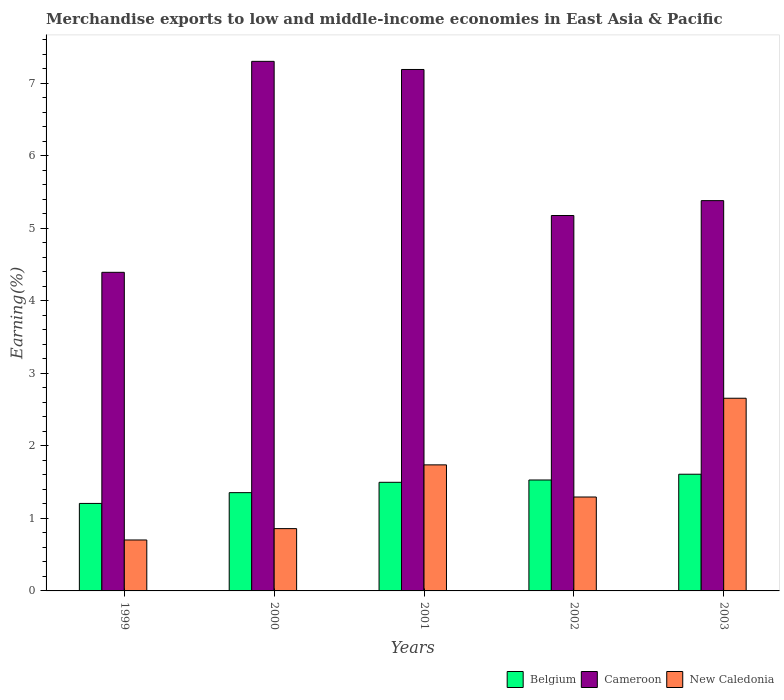How many different coloured bars are there?
Provide a short and direct response. 3. How many groups of bars are there?
Keep it short and to the point. 5. How many bars are there on the 3rd tick from the right?
Provide a succinct answer. 3. What is the percentage of amount earned from merchandise exports in Cameroon in 2002?
Keep it short and to the point. 5.18. Across all years, what is the maximum percentage of amount earned from merchandise exports in Cameroon?
Give a very brief answer. 7.31. Across all years, what is the minimum percentage of amount earned from merchandise exports in Cameroon?
Offer a very short reply. 4.39. In which year was the percentage of amount earned from merchandise exports in Belgium minimum?
Offer a terse response. 1999. What is the total percentage of amount earned from merchandise exports in New Caledonia in the graph?
Your answer should be very brief. 7.25. What is the difference between the percentage of amount earned from merchandise exports in New Caledonia in 2002 and that in 2003?
Provide a succinct answer. -1.36. What is the difference between the percentage of amount earned from merchandise exports in New Caledonia in 2000 and the percentage of amount earned from merchandise exports in Belgium in 2002?
Make the answer very short. -0.67. What is the average percentage of amount earned from merchandise exports in New Caledonia per year?
Offer a very short reply. 1.45. In the year 1999, what is the difference between the percentage of amount earned from merchandise exports in Belgium and percentage of amount earned from merchandise exports in New Caledonia?
Give a very brief answer. 0.5. In how many years, is the percentage of amount earned from merchandise exports in Cameroon greater than 4.6 %?
Offer a terse response. 4. What is the ratio of the percentage of amount earned from merchandise exports in New Caledonia in 2001 to that in 2003?
Offer a very short reply. 0.65. Is the percentage of amount earned from merchandise exports in Belgium in 1999 less than that in 2002?
Your answer should be compact. Yes. What is the difference between the highest and the second highest percentage of amount earned from merchandise exports in Cameroon?
Your response must be concise. 0.11. What is the difference between the highest and the lowest percentage of amount earned from merchandise exports in New Caledonia?
Offer a very short reply. 1.96. What does the 3rd bar from the left in 2003 represents?
Ensure brevity in your answer.  New Caledonia. What does the 3rd bar from the right in 1999 represents?
Offer a terse response. Belgium. Is it the case that in every year, the sum of the percentage of amount earned from merchandise exports in Cameroon and percentage of amount earned from merchandise exports in New Caledonia is greater than the percentage of amount earned from merchandise exports in Belgium?
Provide a succinct answer. Yes. How many years are there in the graph?
Provide a succinct answer. 5. Does the graph contain grids?
Make the answer very short. No. Where does the legend appear in the graph?
Ensure brevity in your answer.  Bottom right. What is the title of the graph?
Provide a succinct answer. Merchandise exports to low and middle-income economies in East Asia & Pacific. What is the label or title of the Y-axis?
Provide a short and direct response. Earning(%). What is the Earning(%) of Belgium in 1999?
Ensure brevity in your answer.  1.21. What is the Earning(%) in Cameroon in 1999?
Offer a terse response. 4.39. What is the Earning(%) in New Caledonia in 1999?
Give a very brief answer. 0.7. What is the Earning(%) in Belgium in 2000?
Offer a very short reply. 1.36. What is the Earning(%) of Cameroon in 2000?
Make the answer very short. 7.31. What is the Earning(%) in New Caledonia in 2000?
Your answer should be compact. 0.86. What is the Earning(%) of Belgium in 2001?
Your answer should be compact. 1.5. What is the Earning(%) of Cameroon in 2001?
Make the answer very short. 7.19. What is the Earning(%) of New Caledonia in 2001?
Provide a succinct answer. 1.74. What is the Earning(%) in Belgium in 2002?
Provide a succinct answer. 1.53. What is the Earning(%) in Cameroon in 2002?
Your answer should be compact. 5.18. What is the Earning(%) in New Caledonia in 2002?
Offer a very short reply. 1.3. What is the Earning(%) in Belgium in 2003?
Your response must be concise. 1.61. What is the Earning(%) of Cameroon in 2003?
Provide a succinct answer. 5.38. What is the Earning(%) in New Caledonia in 2003?
Provide a succinct answer. 2.66. Across all years, what is the maximum Earning(%) of Belgium?
Provide a short and direct response. 1.61. Across all years, what is the maximum Earning(%) in Cameroon?
Provide a short and direct response. 7.31. Across all years, what is the maximum Earning(%) in New Caledonia?
Provide a succinct answer. 2.66. Across all years, what is the minimum Earning(%) of Belgium?
Make the answer very short. 1.21. Across all years, what is the minimum Earning(%) of Cameroon?
Provide a succinct answer. 4.39. Across all years, what is the minimum Earning(%) in New Caledonia?
Offer a terse response. 0.7. What is the total Earning(%) in Belgium in the graph?
Offer a very short reply. 7.2. What is the total Earning(%) of Cameroon in the graph?
Make the answer very short. 29.46. What is the total Earning(%) in New Caledonia in the graph?
Your answer should be compact. 7.25. What is the difference between the Earning(%) of Belgium in 1999 and that in 2000?
Ensure brevity in your answer.  -0.15. What is the difference between the Earning(%) in Cameroon in 1999 and that in 2000?
Your answer should be very brief. -2.91. What is the difference between the Earning(%) of New Caledonia in 1999 and that in 2000?
Your answer should be very brief. -0.16. What is the difference between the Earning(%) in Belgium in 1999 and that in 2001?
Offer a terse response. -0.29. What is the difference between the Earning(%) of Cameroon in 1999 and that in 2001?
Keep it short and to the point. -2.8. What is the difference between the Earning(%) of New Caledonia in 1999 and that in 2001?
Provide a succinct answer. -1.04. What is the difference between the Earning(%) in Belgium in 1999 and that in 2002?
Your response must be concise. -0.32. What is the difference between the Earning(%) in Cameroon in 1999 and that in 2002?
Offer a terse response. -0.78. What is the difference between the Earning(%) in New Caledonia in 1999 and that in 2002?
Your answer should be compact. -0.59. What is the difference between the Earning(%) in Belgium in 1999 and that in 2003?
Keep it short and to the point. -0.4. What is the difference between the Earning(%) of Cameroon in 1999 and that in 2003?
Make the answer very short. -0.99. What is the difference between the Earning(%) of New Caledonia in 1999 and that in 2003?
Keep it short and to the point. -1.96. What is the difference between the Earning(%) in Belgium in 2000 and that in 2001?
Make the answer very short. -0.14. What is the difference between the Earning(%) of Cameroon in 2000 and that in 2001?
Provide a succinct answer. 0.11. What is the difference between the Earning(%) of New Caledonia in 2000 and that in 2001?
Your answer should be very brief. -0.88. What is the difference between the Earning(%) in Belgium in 2000 and that in 2002?
Ensure brevity in your answer.  -0.17. What is the difference between the Earning(%) in Cameroon in 2000 and that in 2002?
Your answer should be very brief. 2.13. What is the difference between the Earning(%) of New Caledonia in 2000 and that in 2002?
Offer a terse response. -0.44. What is the difference between the Earning(%) in Belgium in 2000 and that in 2003?
Give a very brief answer. -0.25. What is the difference between the Earning(%) in Cameroon in 2000 and that in 2003?
Keep it short and to the point. 1.92. What is the difference between the Earning(%) of New Caledonia in 2000 and that in 2003?
Provide a short and direct response. -1.8. What is the difference between the Earning(%) in Belgium in 2001 and that in 2002?
Your response must be concise. -0.03. What is the difference between the Earning(%) in Cameroon in 2001 and that in 2002?
Your answer should be compact. 2.01. What is the difference between the Earning(%) in New Caledonia in 2001 and that in 2002?
Offer a very short reply. 0.44. What is the difference between the Earning(%) of Belgium in 2001 and that in 2003?
Make the answer very short. -0.11. What is the difference between the Earning(%) of Cameroon in 2001 and that in 2003?
Keep it short and to the point. 1.81. What is the difference between the Earning(%) of New Caledonia in 2001 and that in 2003?
Offer a terse response. -0.92. What is the difference between the Earning(%) of Belgium in 2002 and that in 2003?
Your answer should be very brief. -0.08. What is the difference between the Earning(%) of Cameroon in 2002 and that in 2003?
Your answer should be very brief. -0.21. What is the difference between the Earning(%) of New Caledonia in 2002 and that in 2003?
Ensure brevity in your answer.  -1.36. What is the difference between the Earning(%) in Belgium in 1999 and the Earning(%) in Cameroon in 2000?
Make the answer very short. -6.1. What is the difference between the Earning(%) in Belgium in 1999 and the Earning(%) in New Caledonia in 2000?
Provide a short and direct response. 0.35. What is the difference between the Earning(%) of Cameroon in 1999 and the Earning(%) of New Caledonia in 2000?
Make the answer very short. 3.54. What is the difference between the Earning(%) in Belgium in 1999 and the Earning(%) in Cameroon in 2001?
Your answer should be compact. -5.99. What is the difference between the Earning(%) of Belgium in 1999 and the Earning(%) of New Caledonia in 2001?
Offer a very short reply. -0.53. What is the difference between the Earning(%) of Cameroon in 1999 and the Earning(%) of New Caledonia in 2001?
Provide a short and direct response. 2.66. What is the difference between the Earning(%) in Belgium in 1999 and the Earning(%) in Cameroon in 2002?
Provide a short and direct response. -3.97. What is the difference between the Earning(%) of Belgium in 1999 and the Earning(%) of New Caledonia in 2002?
Ensure brevity in your answer.  -0.09. What is the difference between the Earning(%) of Cameroon in 1999 and the Earning(%) of New Caledonia in 2002?
Make the answer very short. 3.1. What is the difference between the Earning(%) in Belgium in 1999 and the Earning(%) in Cameroon in 2003?
Provide a succinct answer. -4.18. What is the difference between the Earning(%) in Belgium in 1999 and the Earning(%) in New Caledonia in 2003?
Your answer should be compact. -1.45. What is the difference between the Earning(%) in Cameroon in 1999 and the Earning(%) in New Caledonia in 2003?
Your answer should be very brief. 1.74. What is the difference between the Earning(%) of Belgium in 2000 and the Earning(%) of Cameroon in 2001?
Keep it short and to the point. -5.84. What is the difference between the Earning(%) of Belgium in 2000 and the Earning(%) of New Caledonia in 2001?
Your response must be concise. -0.38. What is the difference between the Earning(%) of Cameroon in 2000 and the Earning(%) of New Caledonia in 2001?
Keep it short and to the point. 5.57. What is the difference between the Earning(%) in Belgium in 2000 and the Earning(%) in Cameroon in 2002?
Offer a very short reply. -3.82. What is the difference between the Earning(%) of Cameroon in 2000 and the Earning(%) of New Caledonia in 2002?
Make the answer very short. 6.01. What is the difference between the Earning(%) in Belgium in 2000 and the Earning(%) in Cameroon in 2003?
Make the answer very short. -4.03. What is the difference between the Earning(%) in Belgium in 2000 and the Earning(%) in New Caledonia in 2003?
Make the answer very short. -1.3. What is the difference between the Earning(%) of Cameroon in 2000 and the Earning(%) of New Caledonia in 2003?
Your response must be concise. 4.65. What is the difference between the Earning(%) in Belgium in 2001 and the Earning(%) in Cameroon in 2002?
Make the answer very short. -3.68. What is the difference between the Earning(%) in Belgium in 2001 and the Earning(%) in New Caledonia in 2002?
Provide a succinct answer. 0.2. What is the difference between the Earning(%) in Cameroon in 2001 and the Earning(%) in New Caledonia in 2002?
Offer a very short reply. 5.9. What is the difference between the Earning(%) in Belgium in 2001 and the Earning(%) in Cameroon in 2003?
Your response must be concise. -3.89. What is the difference between the Earning(%) of Belgium in 2001 and the Earning(%) of New Caledonia in 2003?
Ensure brevity in your answer.  -1.16. What is the difference between the Earning(%) in Cameroon in 2001 and the Earning(%) in New Caledonia in 2003?
Keep it short and to the point. 4.54. What is the difference between the Earning(%) of Belgium in 2002 and the Earning(%) of Cameroon in 2003?
Keep it short and to the point. -3.85. What is the difference between the Earning(%) of Belgium in 2002 and the Earning(%) of New Caledonia in 2003?
Your response must be concise. -1.13. What is the difference between the Earning(%) in Cameroon in 2002 and the Earning(%) in New Caledonia in 2003?
Offer a terse response. 2.52. What is the average Earning(%) in Belgium per year?
Your answer should be compact. 1.44. What is the average Earning(%) in Cameroon per year?
Provide a succinct answer. 5.89. What is the average Earning(%) in New Caledonia per year?
Make the answer very short. 1.45. In the year 1999, what is the difference between the Earning(%) of Belgium and Earning(%) of Cameroon?
Offer a terse response. -3.19. In the year 1999, what is the difference between the Earning(%) of Belgium and Earning(%) of New Caledonia?
Give a very brief answer. 0.5. In the year 1999, what is the difference between the Earning(%) in Cameroon and Earning(%) in New Caledonia?
Provide a succinct answer. 3.69. In the year 2000, what is the difference between the Earning(%) of Belgium and Earning(%) of Cameroon?
Keep it short and to the point. -5.95. In the year 2000, what is the difference between the Earning(%) of Belgium and Earning(%) of New Caledonia?
Provide a short and direct response. 0.5. In the year 2000, what is the difference between the Earning(%) in Cameroon and Earning(%) in New Caledonia?
Ensure brevity in your answer.  6.45. In the year 2001, what is the difference between the Earning(%) of Belgium and Earning(%) of Cameroon?
Make the answer very short. -5.69. In the year 2001, what is the difference between the Earning(%) in Belgium and Earning(%) in New Caledonia?
Provide a succinct answer. -0.24. In the year 2001, what is the difference between the Earning(%) in Cameroon and Earning(%) in New Caledonia?
Provide a short and direct response. 5.45. In the year 2002, what is the difference between the Earning(%) in Belgium and Earning(%) in Cameroon?
Give a very brief answer. -3.65. In the year 2002, what is the difference between the Earning(%) of Belgium and Earning(%) of New Caledonia?
Your response must be concise. 0.23. In the year 2002, what is the difference between the Earning(%) in Cameroon and Earning(%) in New Caledonia?
Offer a very short reply. 3.88. In the year 2003, what is the difference between the Earning(%) in Belgium and Earning(%) in Cameroon?
Offer a terse response. -3.77. In the year 2003, what is the difference between the Earning(%) of Belgium and Earning(%) of New Caledonia?
Make the answer very short. -1.05. In the year 2003, what is the difference between the Earning(%) of Cameroon and Earning(%) of New Caledonia?
Give a very brief answer. 2.73. What is the ratio of the Earning(%) in Belgium in 1999 to that in 2000?
Offer a very short reply. 0.89. What is the ratio of the Earning(%) of Cameroon in 1999 to that in 2000?
Ensure brevity in your answer.  0.6. What is the ratio of the Earning(%) in New Caledonia in 1999 to that in 2000?
Your answer should be very brief. 0.82. What is the ratio of the Earning(%) of Belgium in 1999 to that in 2001?
Ensure brevity in your answer.  0.81. What is the ratio of the Earning(%) of Cameroon in 1999 to that in 2001?
Make the answer very short. 0.61. What is the ratio of the Earning(%) of New Caledonia in 1999 to that in 2001?
Your answer should be very brief. 0.4. What is the ratio of the Earning(%) in Belgium in 1999 to that in 2002?
Provide a short and direct response. 0.79. What is the ratio of the Earning(%) in Cameroon in 1999 to that in 2002?
Provide a succinct answer. 0.85. What is the ratio of the Earning(%) in New Caledonia in 1999 to that in 2002?
Keep it short and to the point. 0.54. What is the ratio of the Earning(%) in Belgium in 1999 to that in 2003?
Your response must be concise. 0.75. What is the ratio of the Earning(%) in Cameroon in 1999 to that in 2003?
Offer a terse response. 0.82. What is the ratio of the Earning(%) in New Caledonia in 1999 to that in 2003?
Ensure brevity in your answer.  0.26. What is the ratio of the Earning(%) of Belgium in 2000 to that in 2001?
Offer a terse response. 0.9. What is the ratio of the Earning(%) of Cameroon in 2000 to that in 2001?
Keep it short and to the point. 1.02. What is the ratio of the Earning(%) of New Caledonia in 2000 to that in 2001?
Offer a very short reply. 0.49. What is the ratio of the Earning(%) in Belgium in 2000 to that in 2002?
Offer a terse response. 0.89. What is the ratio of the Earning(%) of Cameroon in 2000 to that in 2002?
Give a very brief answer. 1.41. What is the ratio of the Earning(%) in New Caledonia in 2000 to that in 2002?
Keep it short and to the point. 0.66. What is the ratio of the Earning(%) in Belgium in 2000 to that in 2003?
Provide a succinct answer. 0.84. What is the ratio of the Earning(%) in Cameroon in 2000 to that in 2003?
Your answer should be compact. 1.36. What is the ratio of the Earning(%) of New Caledonia in 2000 to that in 2003?
Provide a succinct answer. 0.32. What is the ratio of the Earning(%) in Belgium in 2001 to that in 2002?
Give a very brief answer. 0.98. What is the ratio of the Earning(%) in Cameroon in 2001 to that in 2002?
Ensure brevity in your answer.  1.39. What is the ratio of the Earning(%) in New Caledonia in 2001 to that in 2002?
Provide a succinct answer. 1.34. What is the ratio of the Earning(%) in Belgium in 2001 to that in 2003?
Provide a short and direct response. 0.93. What is the ratio of the Earning(%) in Cameroon in 2001 to that in 2003?
Your answer should be compact. 1.34. What is the ratio of the Earning(%) of New Caledonia in 2001 to that in 2003?
Give a very brief answer. 0.65. What is the ratio of the Earning(%) of Belgium in 2002 to that in 2003?
Offer a terse response. 0.95. What is the ratio of the Earning(%) of Cameroon in 2002 to that in 2003?
Provide a short and direct response. 0.96. What is the ratio of the Earning(%) in New Caledonia in 2002 to that in 2003?
Your answer should be compact. 0.49. What is the difference between the highest and the second highest Earning(%) of Belgium?
Give a very brief answer. 0.08. What is the difference between the highest and the second highest Earning(%) of Cameroon?
Your answer should be compact. 0.11. What is the difference between the highest and the second highest Earning(%) in New Caledonia?
Ensure brevity in your answer.  0.92. What is the difference between the highest and the lowest Earning(%) of Belgium?
Your response must be concise. 0.4. What is the difference between the highest and the lowest Earning(%) in Cameroon?
Your answer should be very brief. 2.91. What is the difference between the highest and the lowest Earning(%) of New Caledonia?
Give a very brief answer. 1.96. 